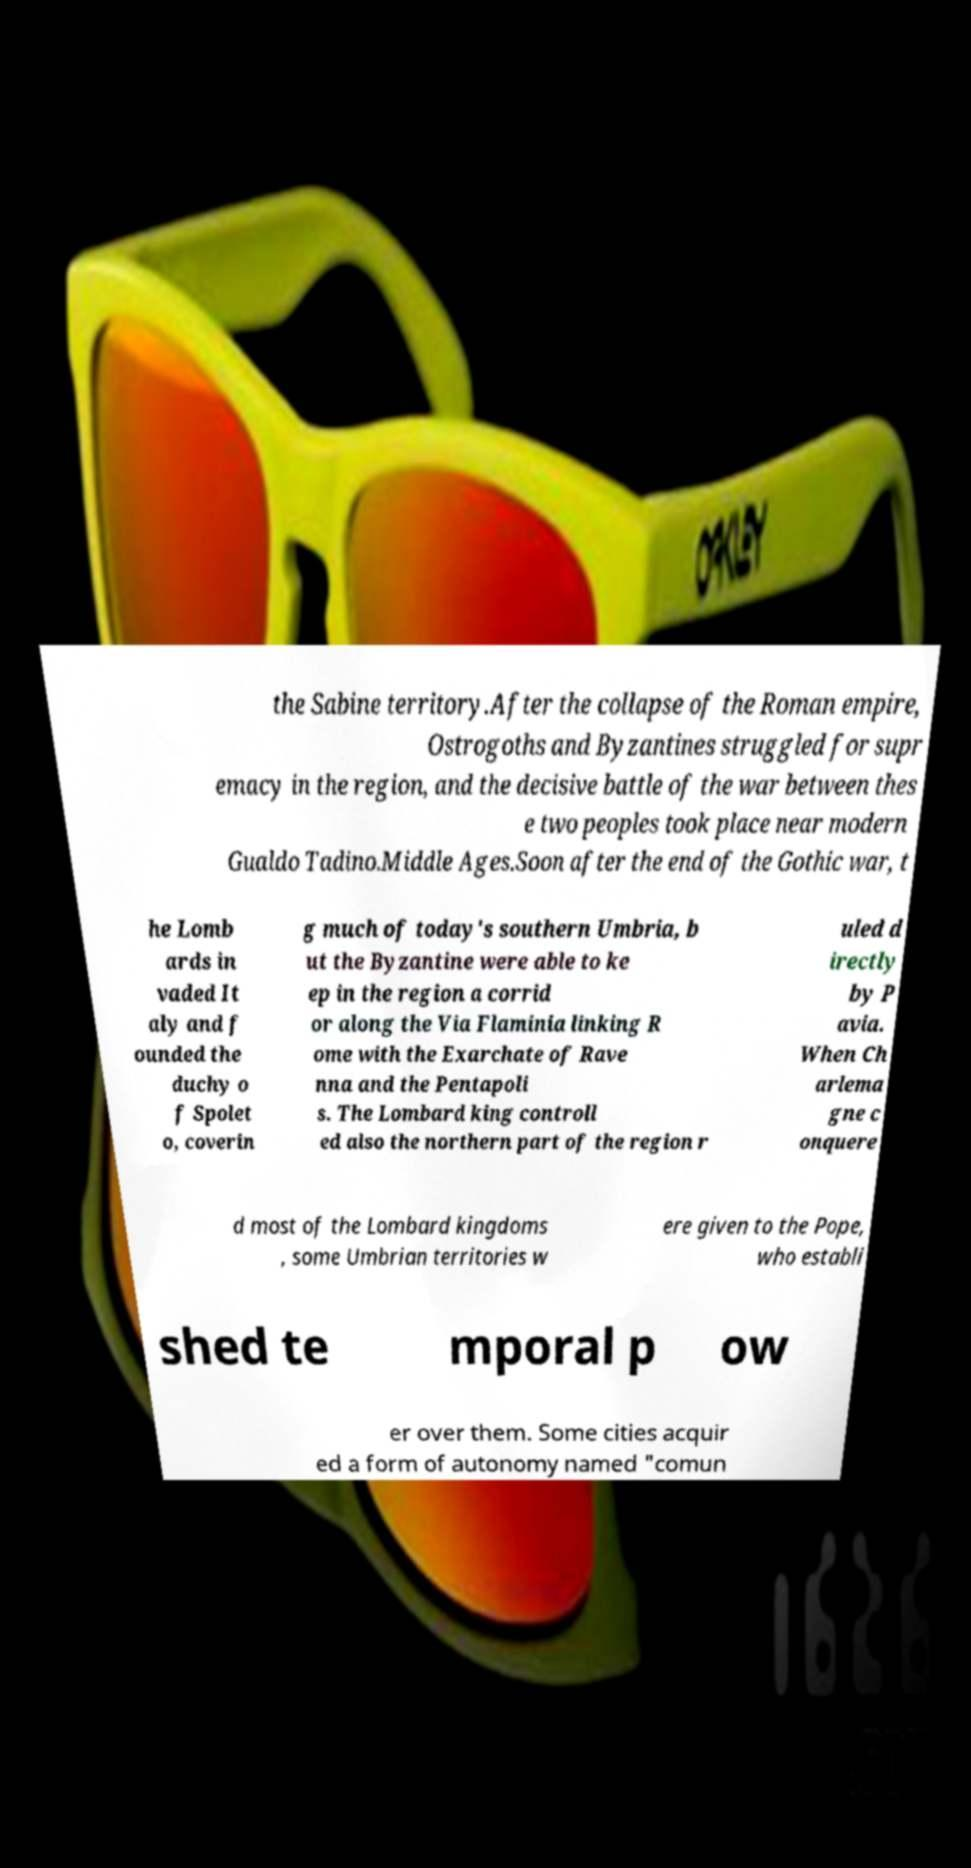Please identify and transcribe the text found in this image. the Sabine territory.After the collapse of the Roman empire, Ostrogoths and Byzantines struggled for supr emacy in the region, and the decisive battle of the war between thes e two peoples took place near modern Gualdo Tadino.Middle Ages.Soon after the end of the Gothic war, t he Lomb ards in vaded It aly and f ounded the duchy o f Spolet o, coverin g much of today's southern Umbria, b ut the Byzantine were able to ke ep in the region a corrid or along the Via Flaminia linking R ome with the Exarchate of Rave nna and the Pentapoli s. The Lombard king controll ed also the northern part of the region r uled d irectly by P avia. When Ch arlema gne c onquere d most of the Lombard kingdoms , some Umbrian territories w ere given to the Pope, who establi shed te mporal p ow er over them. Some cities acquir ed a form of autonomy named "comun 